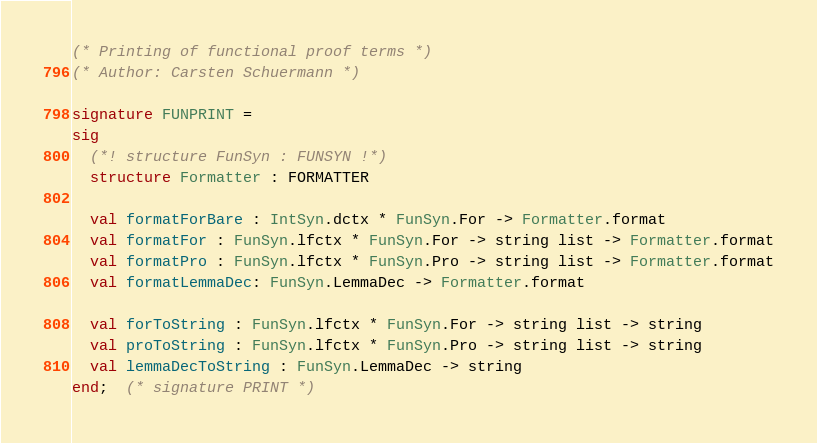<code> <loc_0><loc_0><loc_500><loc_500><_SML_>(* Printing of functional proof terms *)
(* Author: Carsten Schuermann *)

signature FUNPRINT =
sig
  (*! structure FunSyn : FUNSYN !*)
  structure Formatter : FORMATTER

  val formatForBare : IntSyn.dctx * FunSyn.For -> Formatter.format
  val formatFor : FunSyn.lfctx * FunSyn.For -> string list -> Formatter.format
  val formatPro : FunSyn.lfctx * FunSyn.Pro -> string list -> Formatter.format
  val formatLemmaDec: FunSyn.LemmaDec -> Formatter.format

  val forToString : FunSyn.lfctx * FunSyn.For -> string list -> string
  val proToString : FunSyn.lfctx * FunSyn.Pro -> string list -> string
  val lemmaDecToString : FunSyn.LemmaDec -> string
end;  (* signature PRINT *)

</code> 